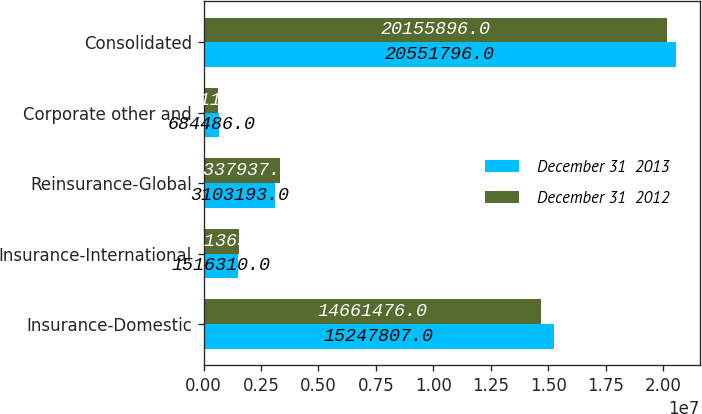Convert chart to OTSL. <chart><loc_0><loc_0><loc_500><loc_500><stacked_bar_chart><ecel><fcel>Insurance-Domestic<fcel>Insurance-International<fcel>Reinsurance-Global<fcel>Corporate other and<fcel>Consolidated<nl><fcel>December 31  2013<fcel>1.52478e+07<fcel>1.51631e+06<fcel>3.10319e+06<fcel>684486<fcel>2.05518e+07<nl><fcel>December 31  2012<fcel>1.46615e+07<fcel>1.54136e+06<fcel>3.33794e+06<fcel>615118<fcel>2.01559e+07<nl></chart> 